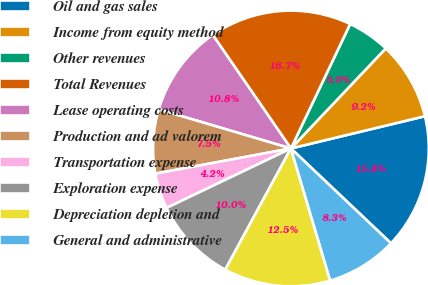Convert chart. <chart><loc_0><loc_0><loc_500><loc_500><pie_chart><fcel>Oil and gas sales<fcel>Income from equity method<fcel>Other revenues<fcel>Total Revenues<fcel>Lease operating costs<fcel>Production and ad valorem<fcel>Transportation expense<fcel>Exploration expense<fcel>Depreciation depletion and<fcel>General and administrative<nl><fcel>15.83%<fcel>9.17%<fcel>5.0%<fcel>16.67%<fcel>10.83%<fcel>7.5%<fcel>4.17%<fcel>10.0%<fcel>12.5%<fcel>8.33%<nl></chart> 